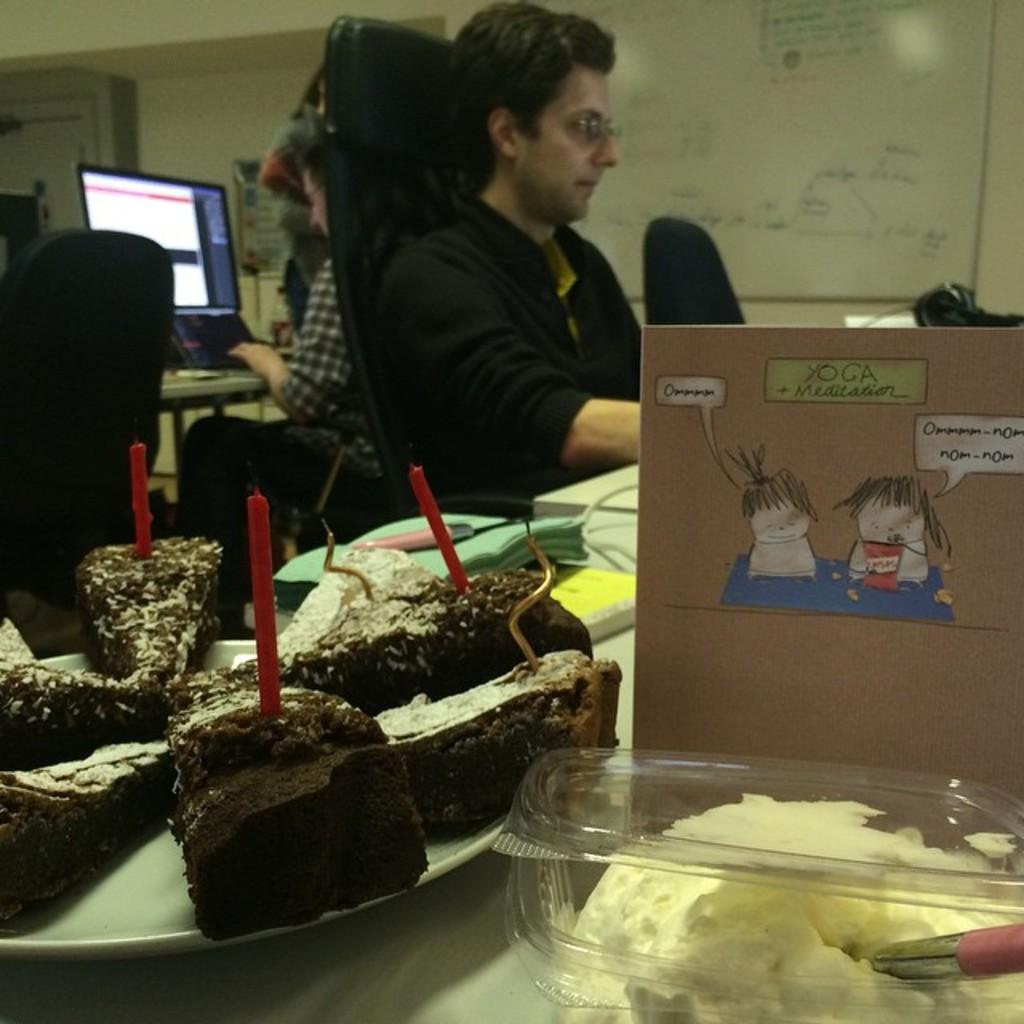How many people are in the image? There are people in the image. What are two of the people doing in the image? Two persons are sitting on chairs in the image. What can be seen on the table in the image? There are objects placed on a table in the image. What type of furniture is present in the image? There are chairs in the image. What type of rake is being used by the person in the image? There is no rake present in the image. Can you describe the square-shaped object on the table in the image? There is no square-shaped object mentioned in the image; the objects on the table are not described in detail. 